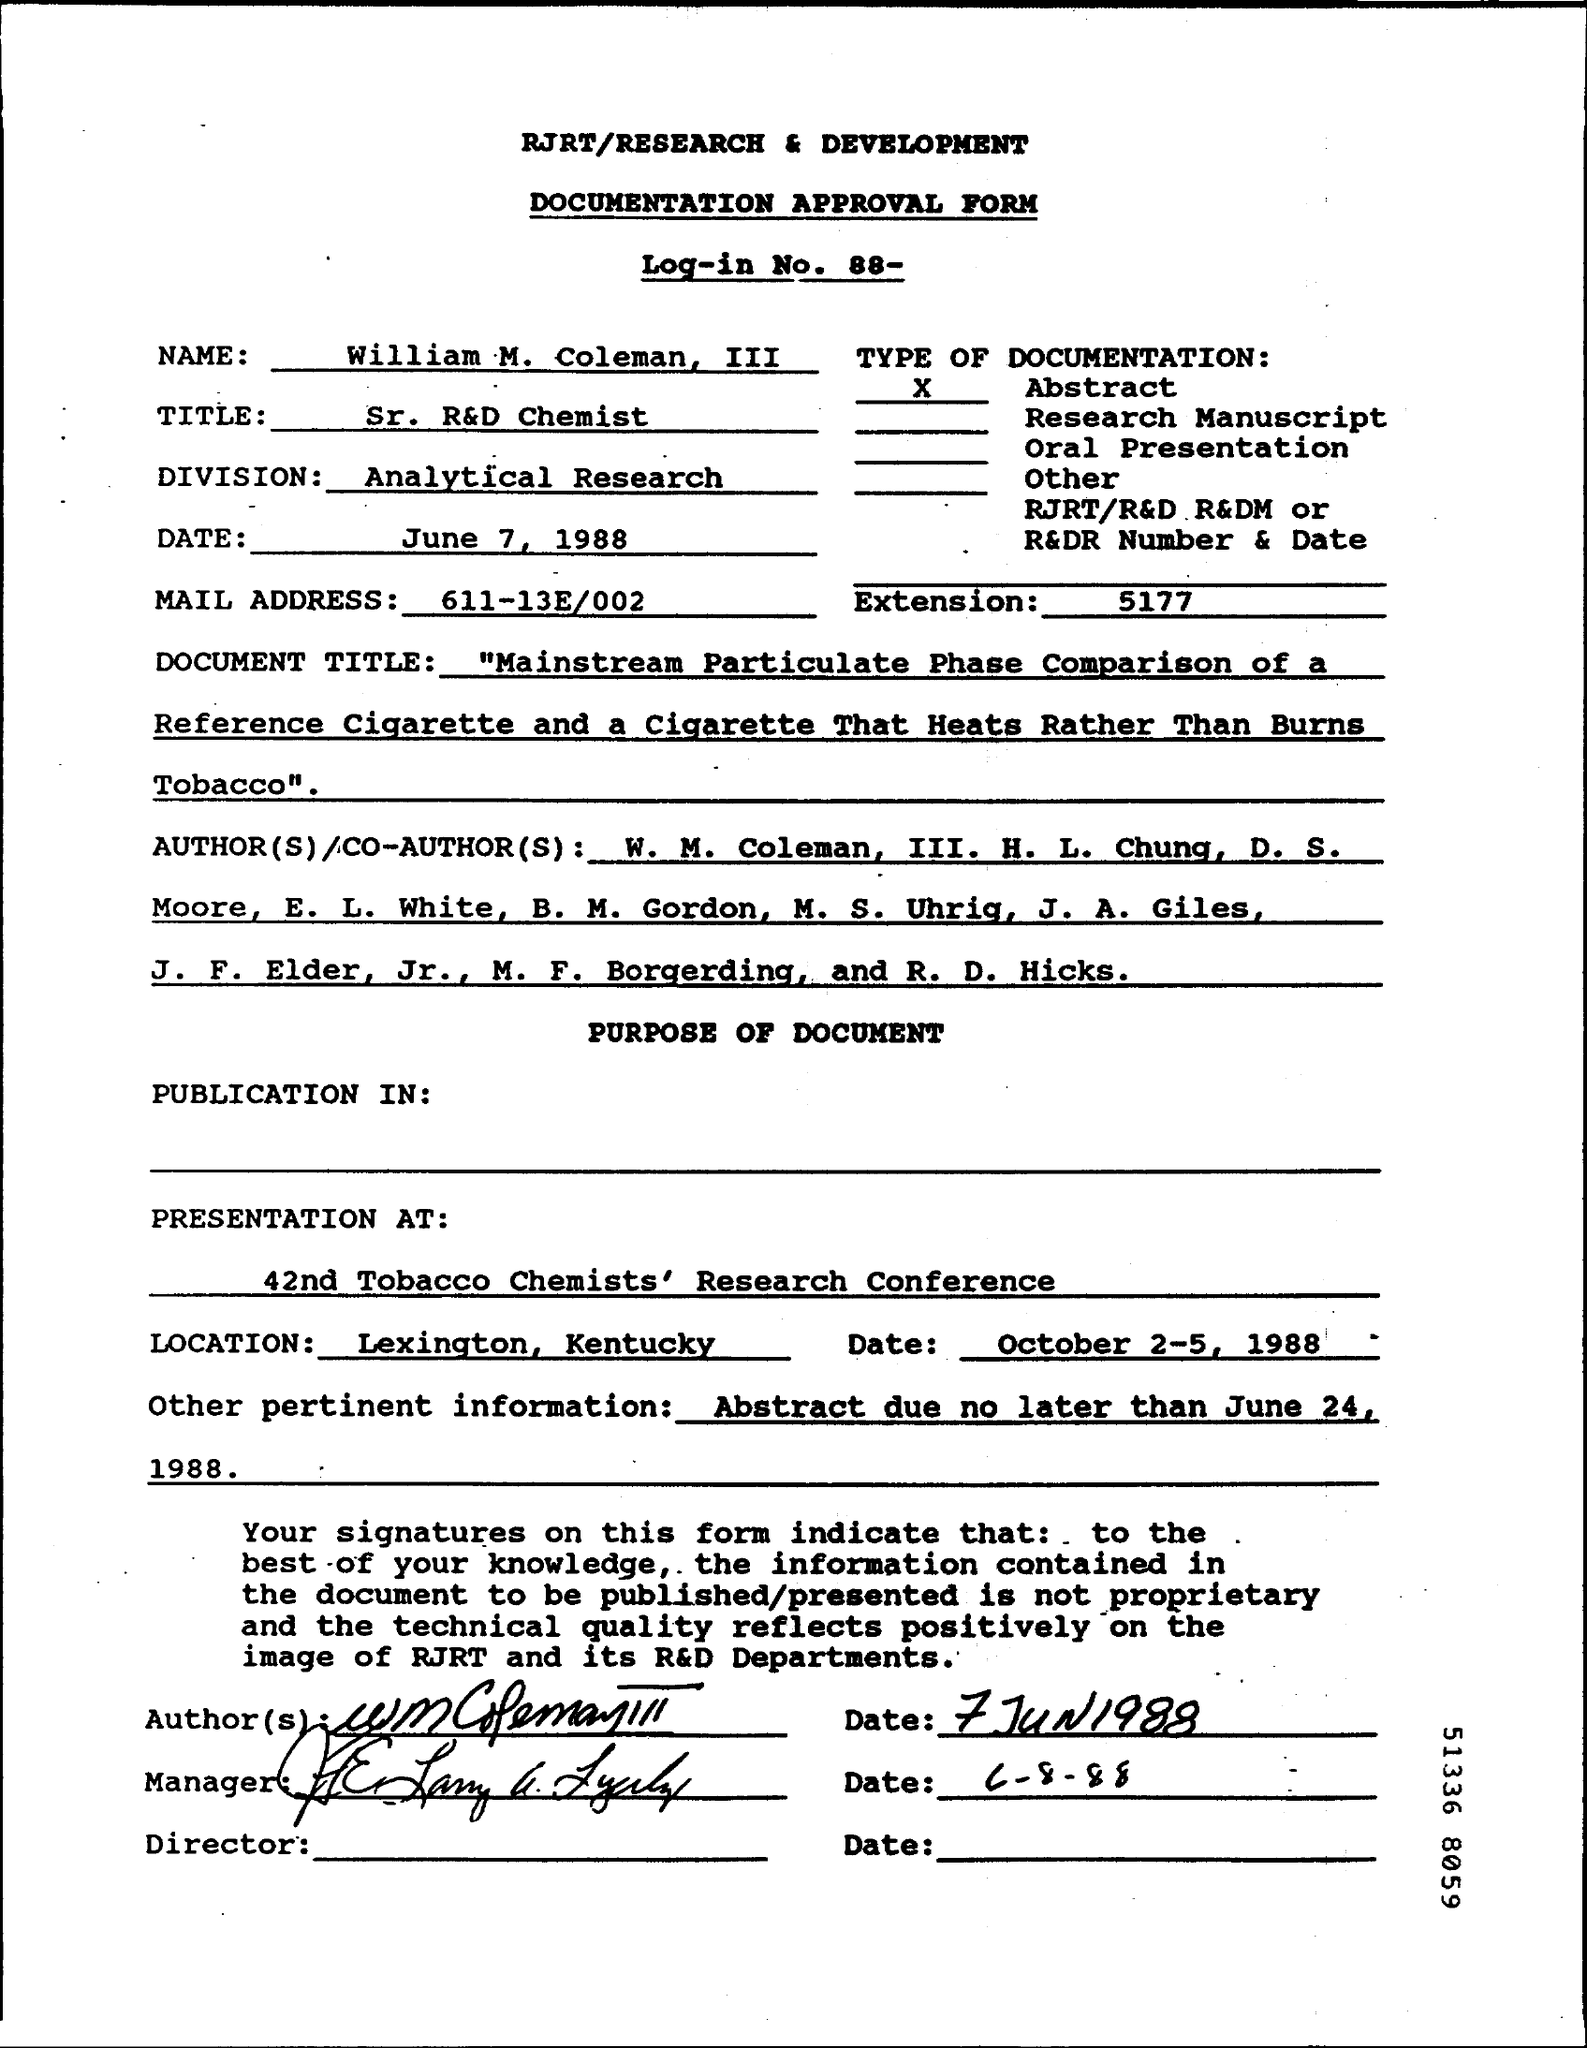What type of form is this?
Offer a very short reply. Documentation approval form. What is the Log-in No.?
Ensure brevity in your answer.  88. What is the name given?
Your answer should be compact. William m. Coleman, III. What is the type of documentation?
Your answer should be compact. Abstract. What is William's title?
Make the answer very short. Sr. r&d chemist. Which is the division mentioned?
Keep it short and to the point. Analytical research. What other pertinent information is given?
Give a very brief answer. Abstract due no later than june 24, 1988. 